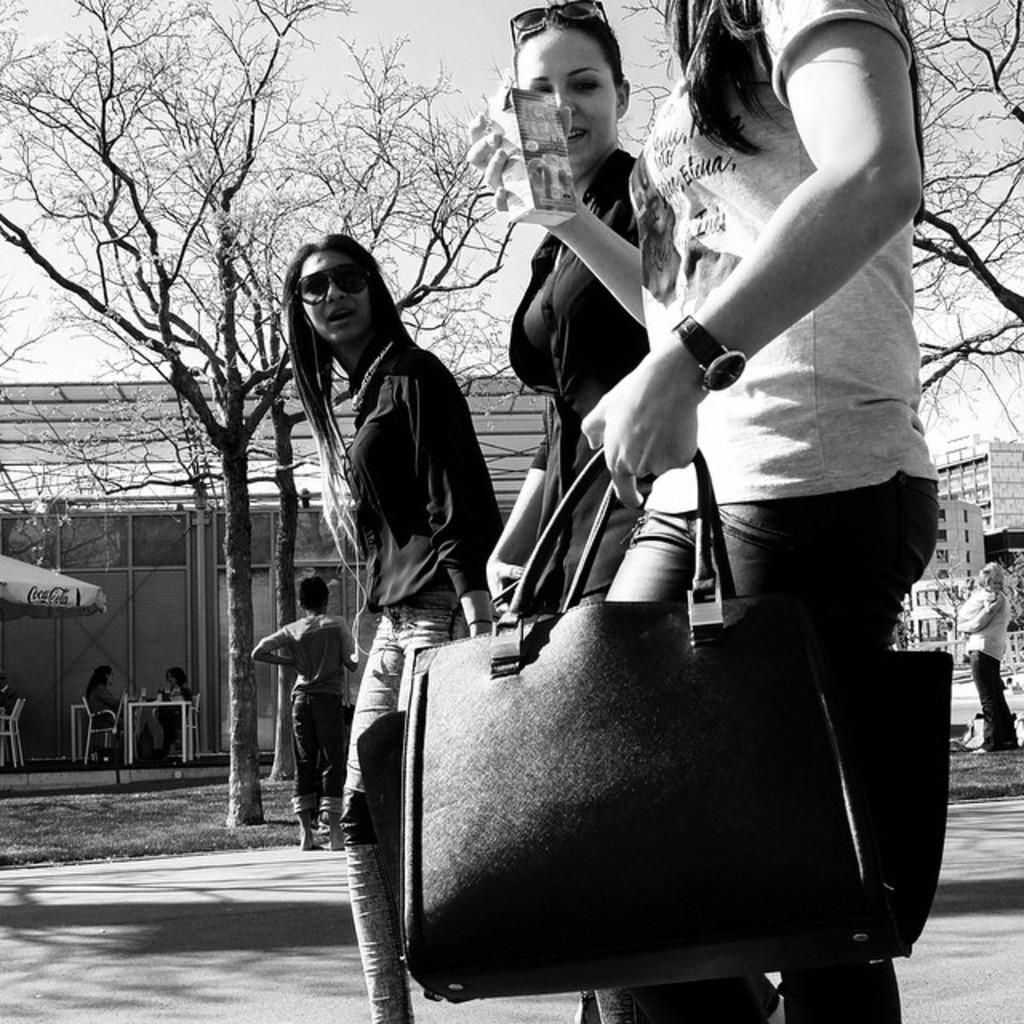Could you give a brief overview of what you see in this image? In this picture we can see three women standing carrying their bags and middle one is smiling and in background we can see house with some more persons sitting on chairs, buildings, trees. 